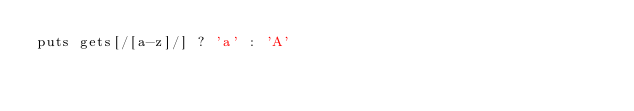Convert code to text. <code><loc_0><loc_0><loc_500><loc_500><_Ruby_>puts gets[/[a-z]/] ? 'a' : 'A'</code> 